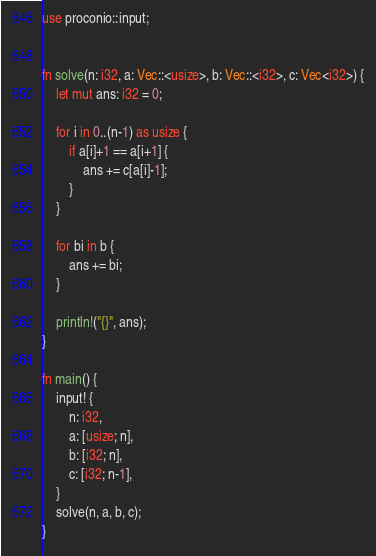Convert code to text. <code><loc_0><loc_0><loc_500><loc_500><_Rust_>use proconio::input;


fn solve(n: i32, a: Vec::<usize>, b: Vec::<i32>, c: Vec<i32>) {
    let mut ans: i32 = 0;

    for i in 0..(n-1) as usize {
        if a[i]+1 == a[i+1] {
            ans += c[a[i]-1];
        }
    }

    for bi in b {
        ans += bi;
    }

    println!("{}", ans);
}

fn main() {
    input! {
        n: i32,
        a: [usize; n],
        b: [i32; n],
        c: [i32; n-1],
    }
    solve(n, a, b, c);
}
</code> 